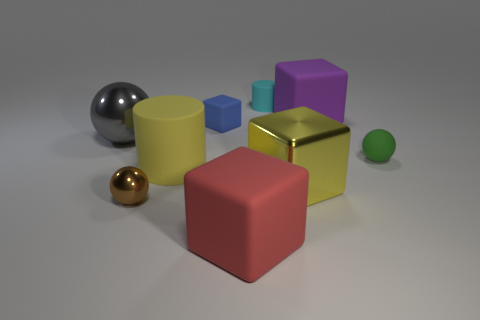Subtract all cyan cylinders. How many cylinders are left? 1 Subtract all green blocks. Subtract all yellow balls. How many blocks are left? 4 Subtract all gray blocks. How many yellow cylinders are left? 1 Subtract all tiny purple metallic balls. Subtract all small cyan cylinders. How many objects are left? 8 Add 2 shiny spheres. How many shiny spheres are left? 4 Add 8 large cyan matte cylinders. How many large cyan matte cylinders exist? 8 Subtract all metallic blocks. How many blocks are left? 3 Subtract 0 red cylinders. How many objects are left? 9 Subtract all cylinders. How many objects are left? 7 Subtract 4 blocks. How many blocks are left? 0 